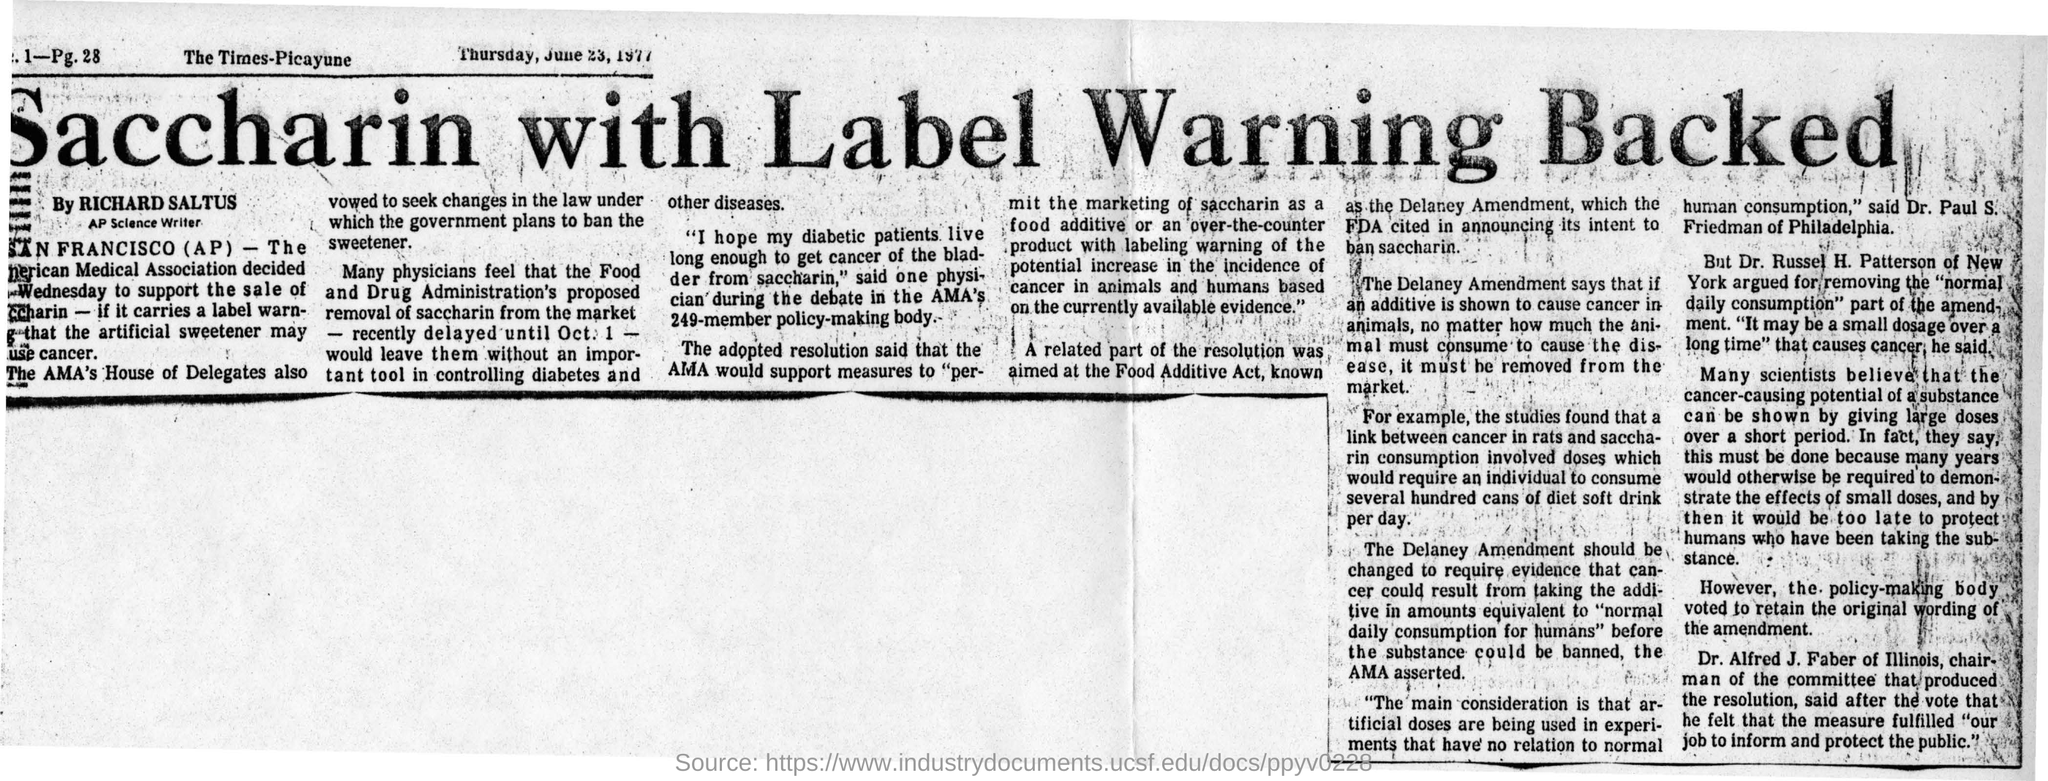What is the name of the newspaper?
Ensure brevity in your answer.  The Times-Picayune. What is the date mentioned in the newspaper?
Offer a very short reply. Thursday, June 23, 1977. What is the head line of the news?
Ensure brevity in your answer.  Saccharin with Label Warning Backed. Who is the AP Science Writer?
Your response must be concise. Richard Saltus. 